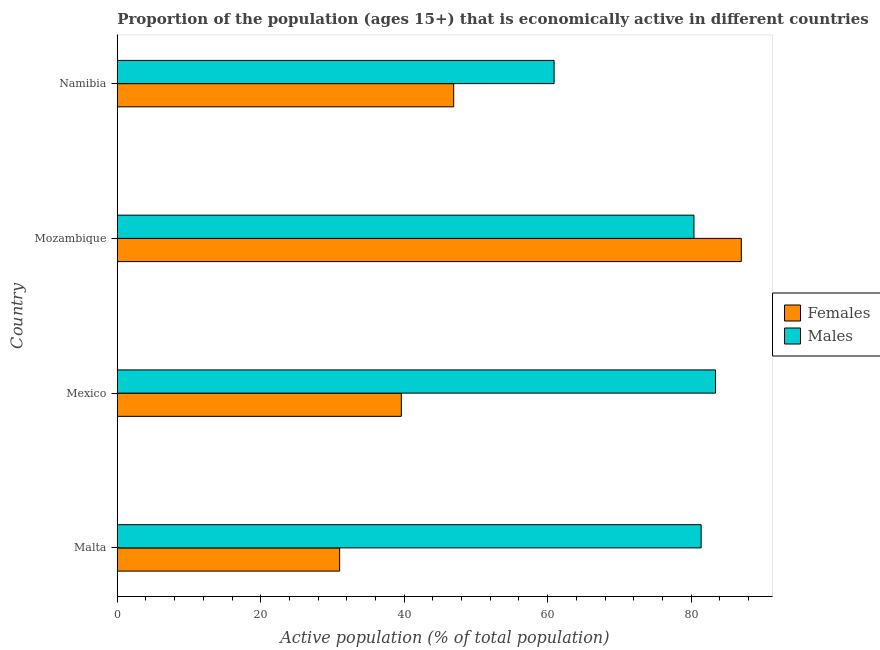How many groups of bars are there?
Your answer should be very brief. 4. Are the number of bars per tick equal to the number of legend labels?
Your response must be concise. Yes. How many bars are there on the 3rd tick from the top?
Provide a succinct answer. 2. Across all countries, what is the minimum percentage of economically active female population?
Ensure brevity in your answer.  31. In which country was the percentage of economically active male population minimum?
Make the answer very short. Namibia. What is the total percentage of economically active female population in the graph?
Your answer should be compact. 204.5. What is the difference between the percentage of economically active male population in Mexico and that in Mozambique?
Provide a short and direct response. 3. What is the difference between the percentage of economically active male population in Mexico and the percentage of economically active female population in Malta?
Ensure brevity in your answer.  52.4. What is the average percentage of economically active male population per country?
Your answer should be very brief. 76.53. What is the difference between the percentage of economically active male population and percentage of economically active female population in Mexico?
Your response must be concise. 43.8. Is the percentage of economically active male population in Malta less than that in Namibia?
Keep it short and to the point. No. Is the difference between the percentage of economically active male population in Malta and Mexico greater than the difference between the percentage of economically active female population in Malta and Mexico?
Offer a terse response. Yes. What is the difference between the highest and the second highest percentage of economically active female population?
Provide a succinct answer. 40.1. What is the difference between the highest and the lowest percentage of economically active female population?
Give a very brief answer. 56. In how many countries, is the percentage of economically active female population greater than the average percentage of economically active female population taken over all countries?
Provide a succinct answer. 1. What does the 2nd bar from the top in Mozambique represents?
Your response must be concise. Females. What does the 2nd bar from the bottom in Malta represents?
Offer a very short reply. Males. How many countries are there in the graph?
Keep it short and to the point. 4. What is the difference between two consecutive major ticks on the X-axis?
Keep it short and to the point. 20. Are the values on the major ticks of X-axis written in scientific E-notation?
Offer a very short reply. No. Where does the legend appear in the graph?
Keep it short and to the point. Center right. How many legend labels are there?
Your response must be concise. 2. How are the legend labels stacked?
Ensure brevity in your answer.  Vertical. What is the title of the graph?
Ensure brevity in your answer.  Proportion of the population (ages 15+) that is economically active in different countries. Does "Primary education" appear as one of the legend labels in the graph?
Keep it short and to the point. No. What is the label or title of the X-axis?
Give a very brief answer. Active population (% of total population). What is the Active population (% of total population) of Males in Malta?
Give a very brief answer. 81.4. What is the Active population (% of total population) in Females in Mexico?
Offer a terse response. 39.6. What is the Active population (% of total population) of Males in Mexico?
Keep it short and to the point. 83.4. What is the Active population (% of total population) of Females in Mozambique?
Your response must be concise. 87. What is the Active population (% of total population) in Males in Mozambique?
Give a very brief answer. 80.4. What is the Active population (% of total population) in Females in Namibia?
Give a very brief answer. 46.9. What is the Active population (% of total population) of Males in Namibia?
Keep it short and to the point. 60.9. Across all countries, what is the maximum Active population (% of total population) of Females?
Provide a short and direct response. 87. Across all countries, what is the maximum Active population (% of total population) in Males?
Offer a terse response. 83.4. Across all countries, what is the minimum Active population (% of total population) of Females?
Give a very brief answer. 31. Across all countries, what is the minimum Active population (% of total population) of Males?
Keep it short and to the point. 60.9. What is the total Active population (% of total population) of Females in the graph?
Your response must be concise. 204.5. What is the total Active population (% of total population) in Males in the graph?
Provide a succinct answer. 306.1. What is the difference between the Active population (% of total population) of Females in Malta and that in Mozambique?
Offer a terse response. -56. What is the difference between the Active population (% of total population) in Females in Malta and that in Namibia?
Your answer should be very brief. -15.9. What is the difference between the Active population (% of total population) in Females in Mexico and that in Mozambique?
Your response must be concise. -47.4. What is the difference between the Active population (% of total population) of Females in Mexico and that in Namibia?
Your response must be concise. -7.3. What is the difference between the Active population (% of total population) in Females in Mozambique and that in Namibia?
Provide a succinct answer. 40.1. What is the difference between the Active population (% of total population) in Males in Mozambique and that in Namibia?
Ensure brevity in your answer.  19.5. What is the difference between the Active population (% of total population) in Females in Malta and the Active population (% of total population) in Males in Mexico?
Your response must be concise. -52.4. What is the difference between the Active population (% of total population) of Females in Malta and the Active population (% of total population) of Males in Mozambique?
Offer a very short reply. -49.4. What is the difference between the Active population (% of total population) of Females in Malta and the Active population (% of total population) of Males in Namibia?
Keep it short and to the point. -29.9. What is the difference between the Active population (% of total population) in Females in Mexico and the Active population (% of total population) in Males in Mozambique?
Your answer should be compact. -40.8. What is the difference between the Active population (% of total population) of Females in Mexico and the Active population (% of total population) of Males in Namibia?
Offer a very short reply. -21.3. What is the difference between the Active population (% of total population) in Females in Mozambique and the Active population (% of total population) in Males in Namibia?
Provide a succinct answer. 26.1. What is the average Active population (% of total population) of Females per country?
Ensure brevity in your answer.  51.12. What is the average Active population (% of total population) in Males per country?
Provide a succinct answer. 76.53. What is the difference between the Active population (% of total population) in Females and Active population (% of total population) in Males in Malta?
Your response must be concise. -50.4. What is the difference between the Active population (% of total population) in Females and Active population (% of total population) in Males in Mexico?
Give a very brief answer. -43.8. What is the difference between the Active population (% of total population) of Females and Active population (% of total population) of Males in Mozambique?
Give a very brief answer. 6.6. What is the difference between the Active population (% of total population) of Females and Active population (% of total population) of Males in Namibia?
Your answer should be very brief. -14. What is the ratio of the Active population (% of total population) in Females in Malta to that in Mexico?
Ensure brevity in your answer.  0.78. What is the ratio of the Active population (% of total population) of Females in Malta to that in Mozambique?
Provide a short and direct response. 0.36. What is the ratio of the Active population (% of total population) in Males in Malta to that in Mozambique?
Offer a very short reply. 1.01. What is the ratio of the Active population (% of total population) in Females in Malta to that in Namibia?
Provide a succinct answer. 0.66. What is the ratio of the Active population (% of total population) of Males in Malta to that in Namibia?
Make the answer very short. 1.34. What is the ratio of the Active population (% of total population) in Females in Mexico to that in Mozambique?
Give a very brief answer. 0.46. What is the ratio of the Active population (% of total population) of Males in Mexico to that in Mozambique?
Provide a succinct answer. 1.04. What is the ratio of the Active population (% of total population) of Females in Mexico to that in Namibia?
Make the answer very short. 0.84. What is the ratio of the Active population (% of total population) of Males in Mexico to that in Namibia?
Offer a terse response. 1.37. What is the ratio of the Active population (% of total population) of Females in Mozambique to that in Namibia?
Make the answer very short. 1.85. What is the ratio of the Active population (% of total population) of Males in Mozambique to that in Namibia?
Your answer should be very brief. 1.32. What is the difference between the highest and the second highest Active population (% of total population) of Females?
Your answer should be compact. 40.1. What is the difference between the highest and the second highest Active population (% of total population) in Males?
Give a very brief answer. 2. What is the difference between the highest and the lowest Active population (% of total population) in Females?
Ensure brevity in your answer.  56. What is the difference between the highest and the lowest Active population (% of total population) of Males?
Keep it short and to the point. 22.5. 